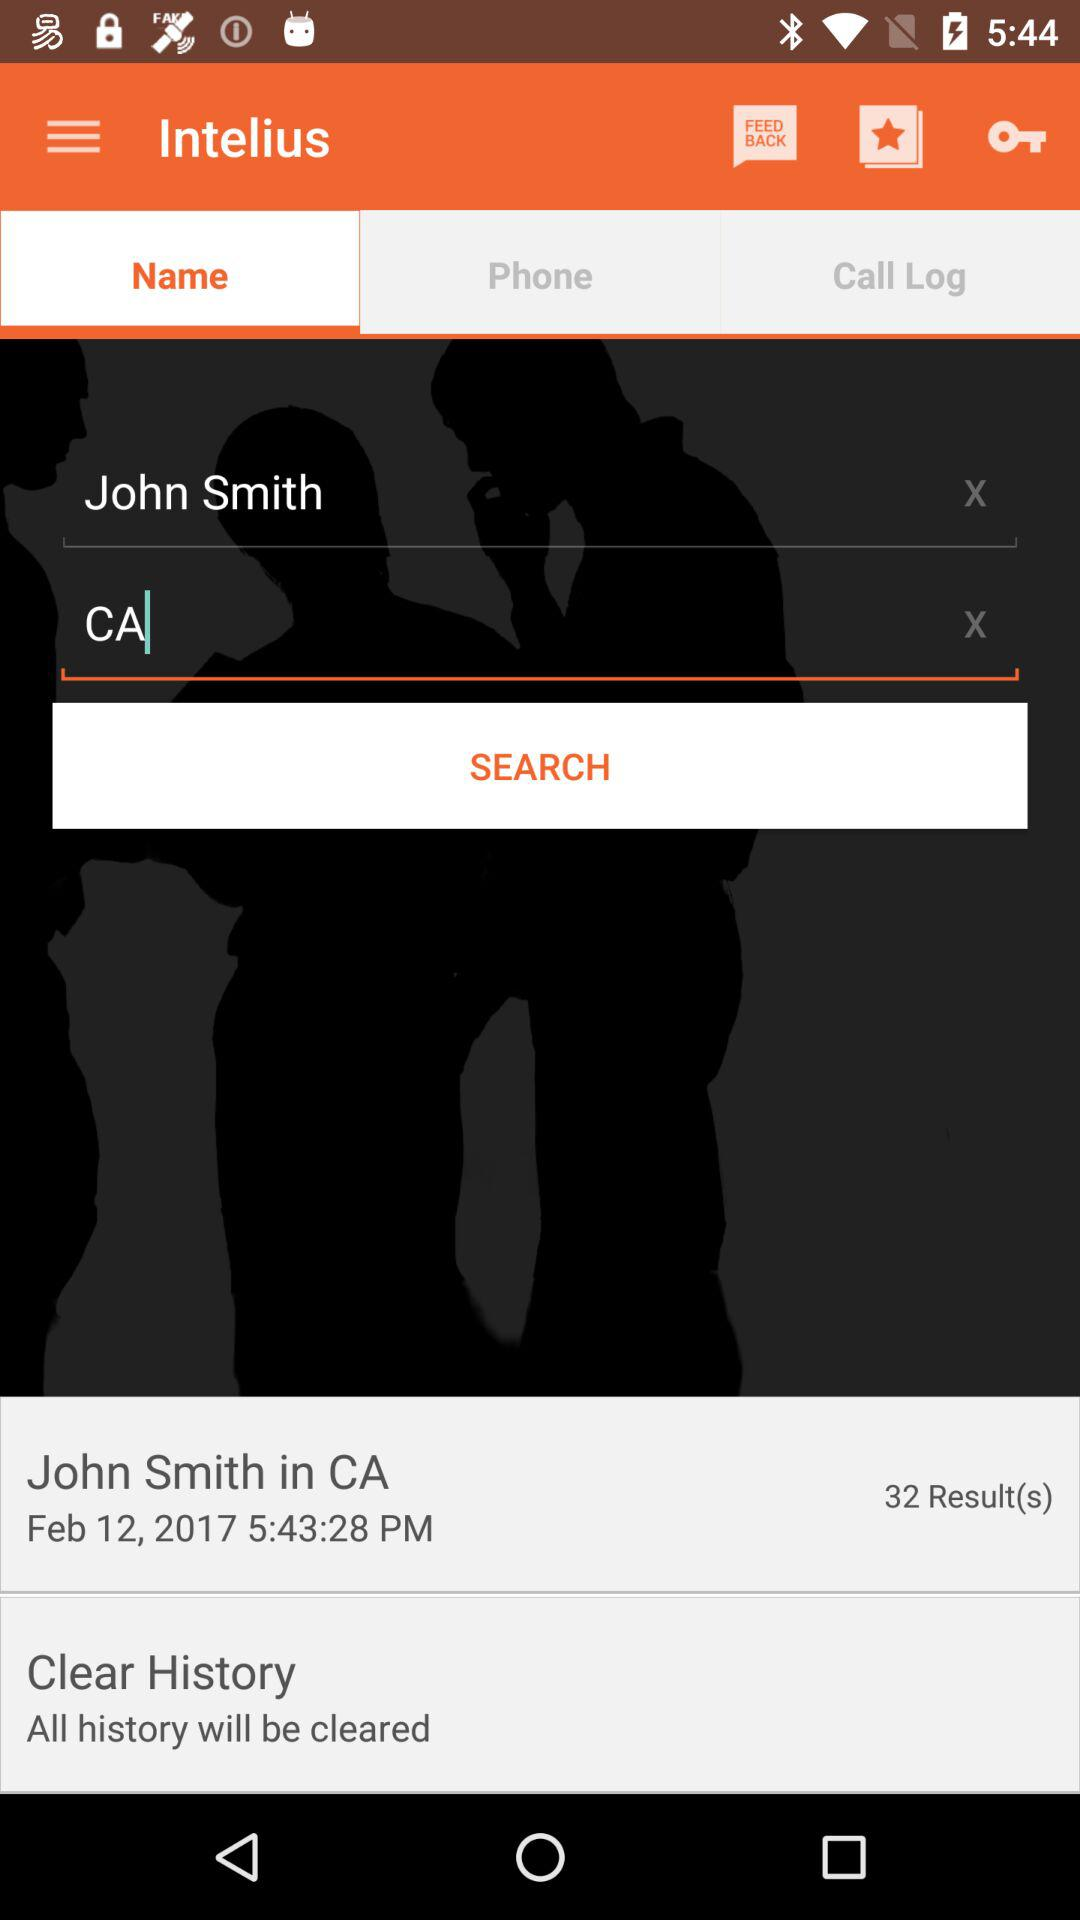How many results are there?
Answer the question using a single word or phrase. 32 